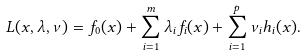<formula> <loc_0><loc_0><loc_500><loc_500>L ( x , \lambda , \nu ) = f _ { 0 } ( x ) + \sum _ { i = 1 } ^ { m } \lambda _ { i } f _ { i } ( x ) + \sum _ { i = 1 } ^ { p } \nu _ { i } h _ { i } ( x ) .</formula> 